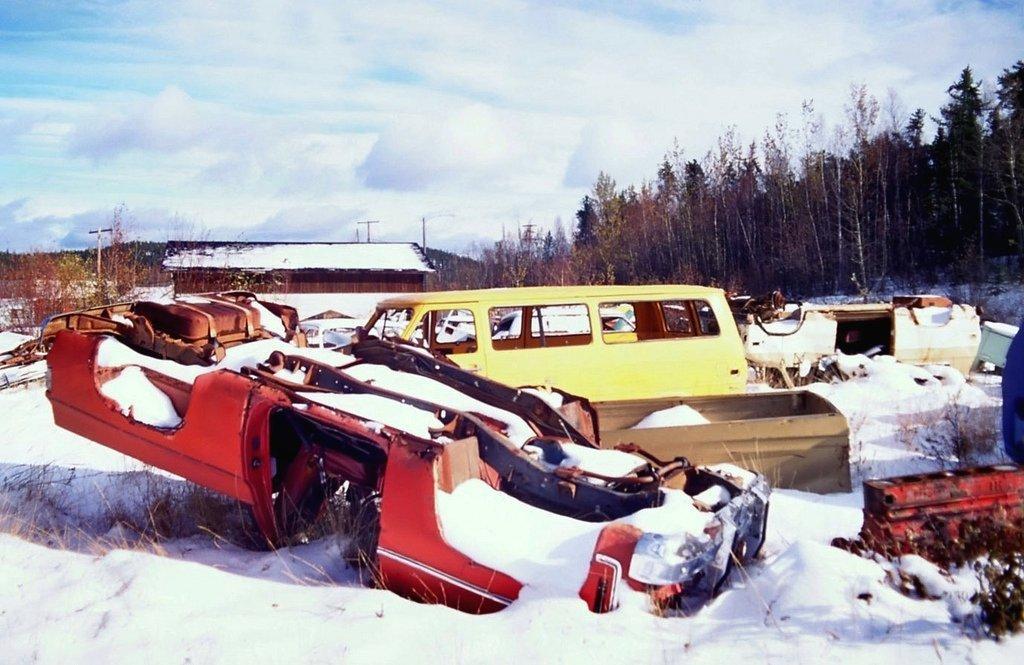Could you give a brief overview of what you see in this image? In this picture we can observe yellow color vehicle on the snow. We can observe some snow on the land. In the background we can observe a house. There are some trees. There is a sky with some clouds. 